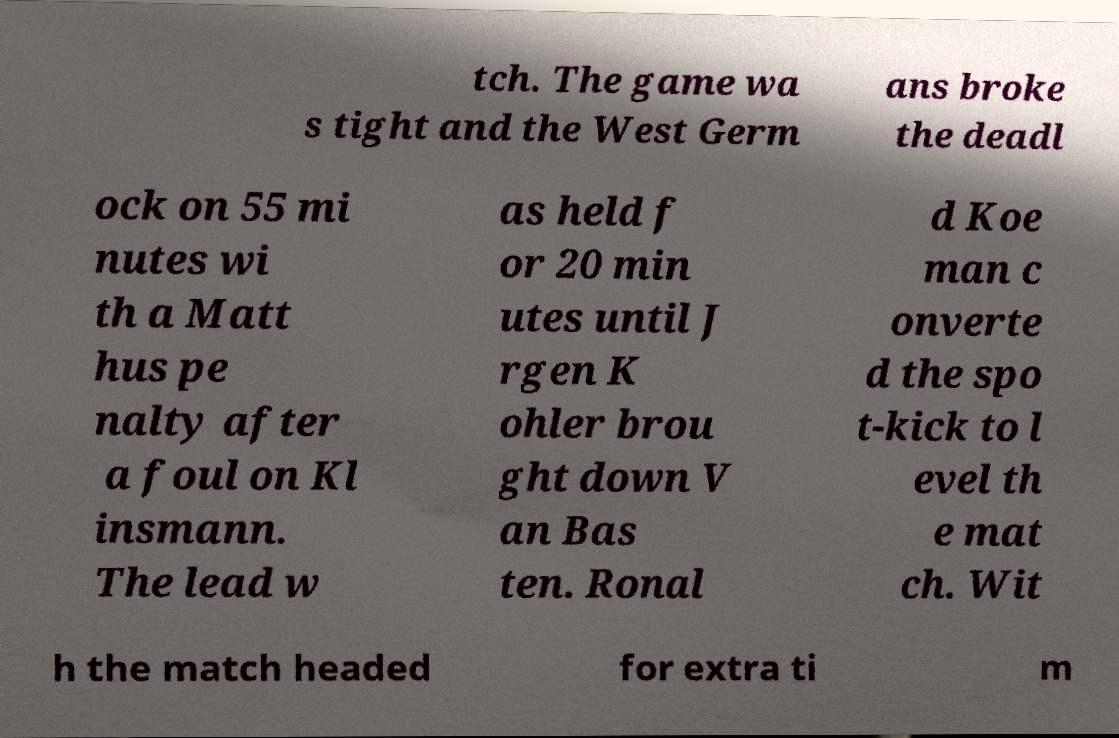For documentation purposes, I need the text within this image transcribed. Could you provide that? tch. The game wa s tight and the West Germ ans broke the deadl ock on 55 mi nutes wi th a Matt hus pe nalty after a foul on Kl insmann. The lead w as held f or 20 min utes until J rgen K ohler brou ght down V an Bas ten. Ronal d Koe man c onverte d the spo t-kick to l evel th e mat ch. Wit h the match headed for extra ti m 